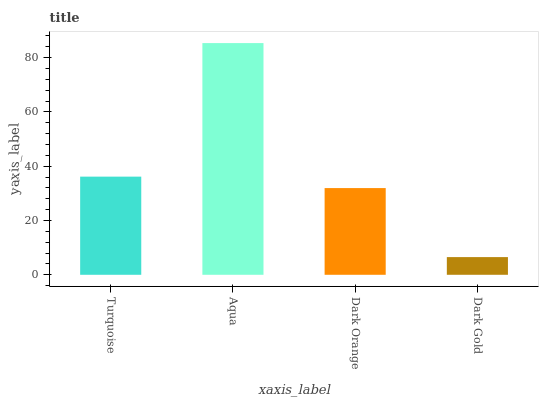Is Dark Orange the minimum?
Answer yes or no. No. Is Dark Orange the maximum?
Answer yes or no. No. Is Aqua greater than Dark Orange?
Answer yes or no. Yes. Is Dark Orange less than Aqua?
Answer yes or no. Yes. Is Dark Orange greater than Aqua?
Answer yes or no. No. Is Aqua less than Dark Orange?
Answer yes or no. No. Is Turquoise the high median?
Answer yes or no. Yes. Is Dark Orange the low median?
Answer yes or no. Yes. Is Aqua the high median?
Answer yes or no. No. Is Dark Gold the low median?
Answer yes or no. No. 